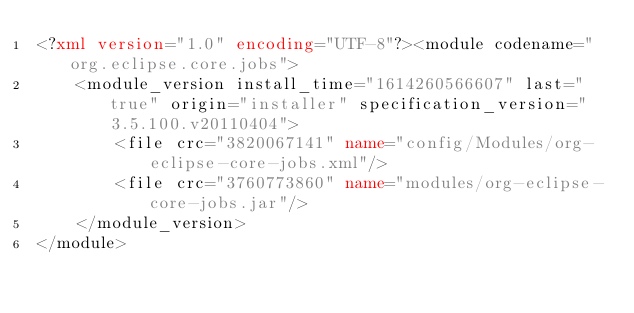<code> <loc_0><loc_0><loc_500><loc_500><_XML_><?xml version="1.0" encoding="UTF-8"?><module codename="org.eclipse.core.jobs">
    <module_version install_time="1614260566607" last="true" origin="installer" specification_version="3.5.100.v20110404">
        <file crc="3820067141" name="config/Modules/org-eclipse-core-jobs.xml"/>
        <file crc="3760773860" name="modules/org-eclipse-core-jobs.jar"/>
    </module_version>
</module>
</code> 